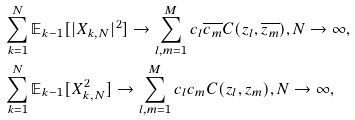Convert formula to latex. <formula><loc_0><loc_0><loc_500><loc_500>& \sum _ { k = 1 } ^ { N } \mathbb { E } _ { k - 1 } [ | X _ { k , N } | ^ { 2 } ] \rightarrow \sum _ { l , m = 1 } ^ { M } c _ { l } \overline { c _ { m } } C ( z _ { l } , \overline { z _ { m } } ) , N \to \infty , \\ & \sum _ { k = 1 } ^ { N } \mathbb { E } _ { k - 1 } [ X _ { k , N } ^ { 2 } ] \rightarrow \sum _ { l , m = 1 } ^ { M } c _ { l } c _ { m } C ( z _ { l } , z _ { m } ) , N \to \infty ,</formula> 